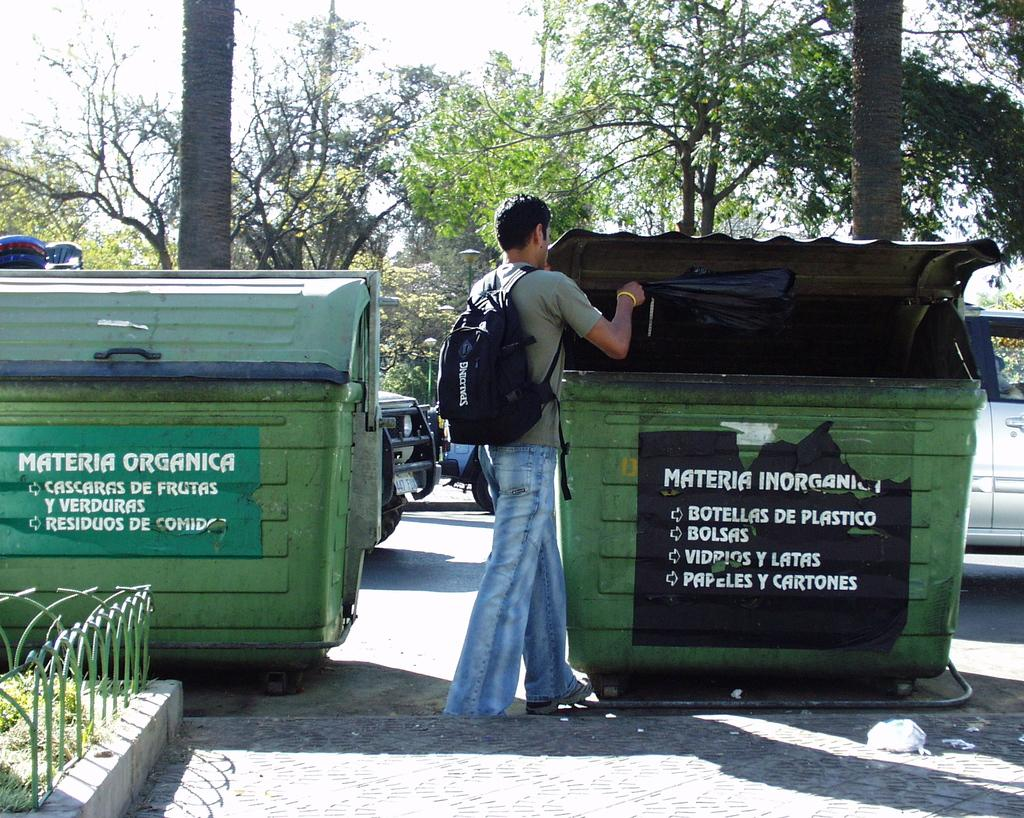<image>
Relay a brief, clear account of the picture shown. Man wearing a backpack standing in front of a garbage can that says "Materia". 